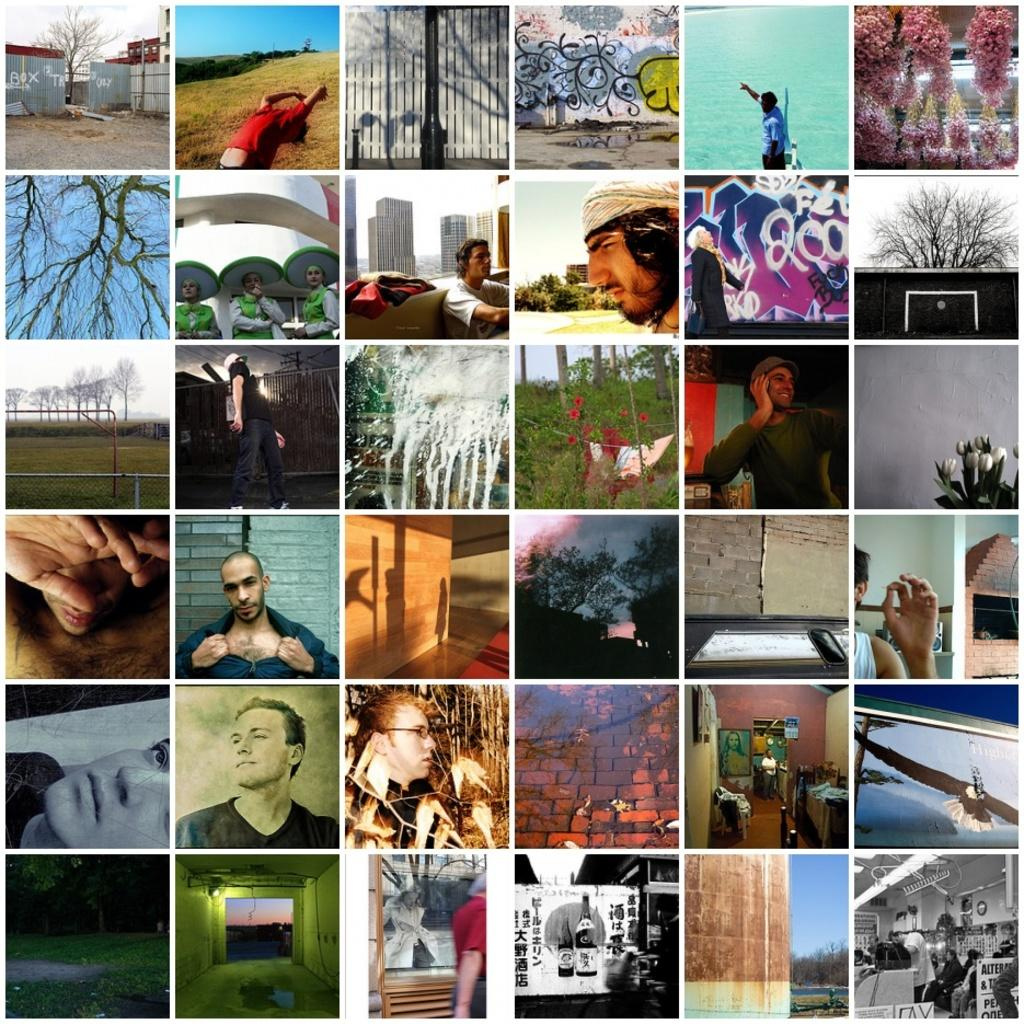What type of artwork is featured in the image? The image contains a collage. What type of oil can be seen dripping from the collage in the image? There is no oil present in the image, as it features a collage. How many sisters are depicted in the collage? There is no mention of sisters or any people in the image, as it only features a collage. 